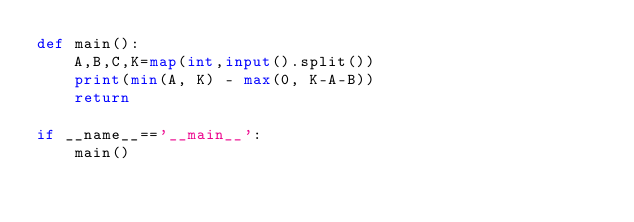<code> <loc_0><loc_0><loc_500><loc_500><_Python_>def main():
    A,B,C,K=map(int,input().split())
    print(min(A, K) - max(0, K-A-B))
    return

if __name__=='__main__':
    main()</code> 